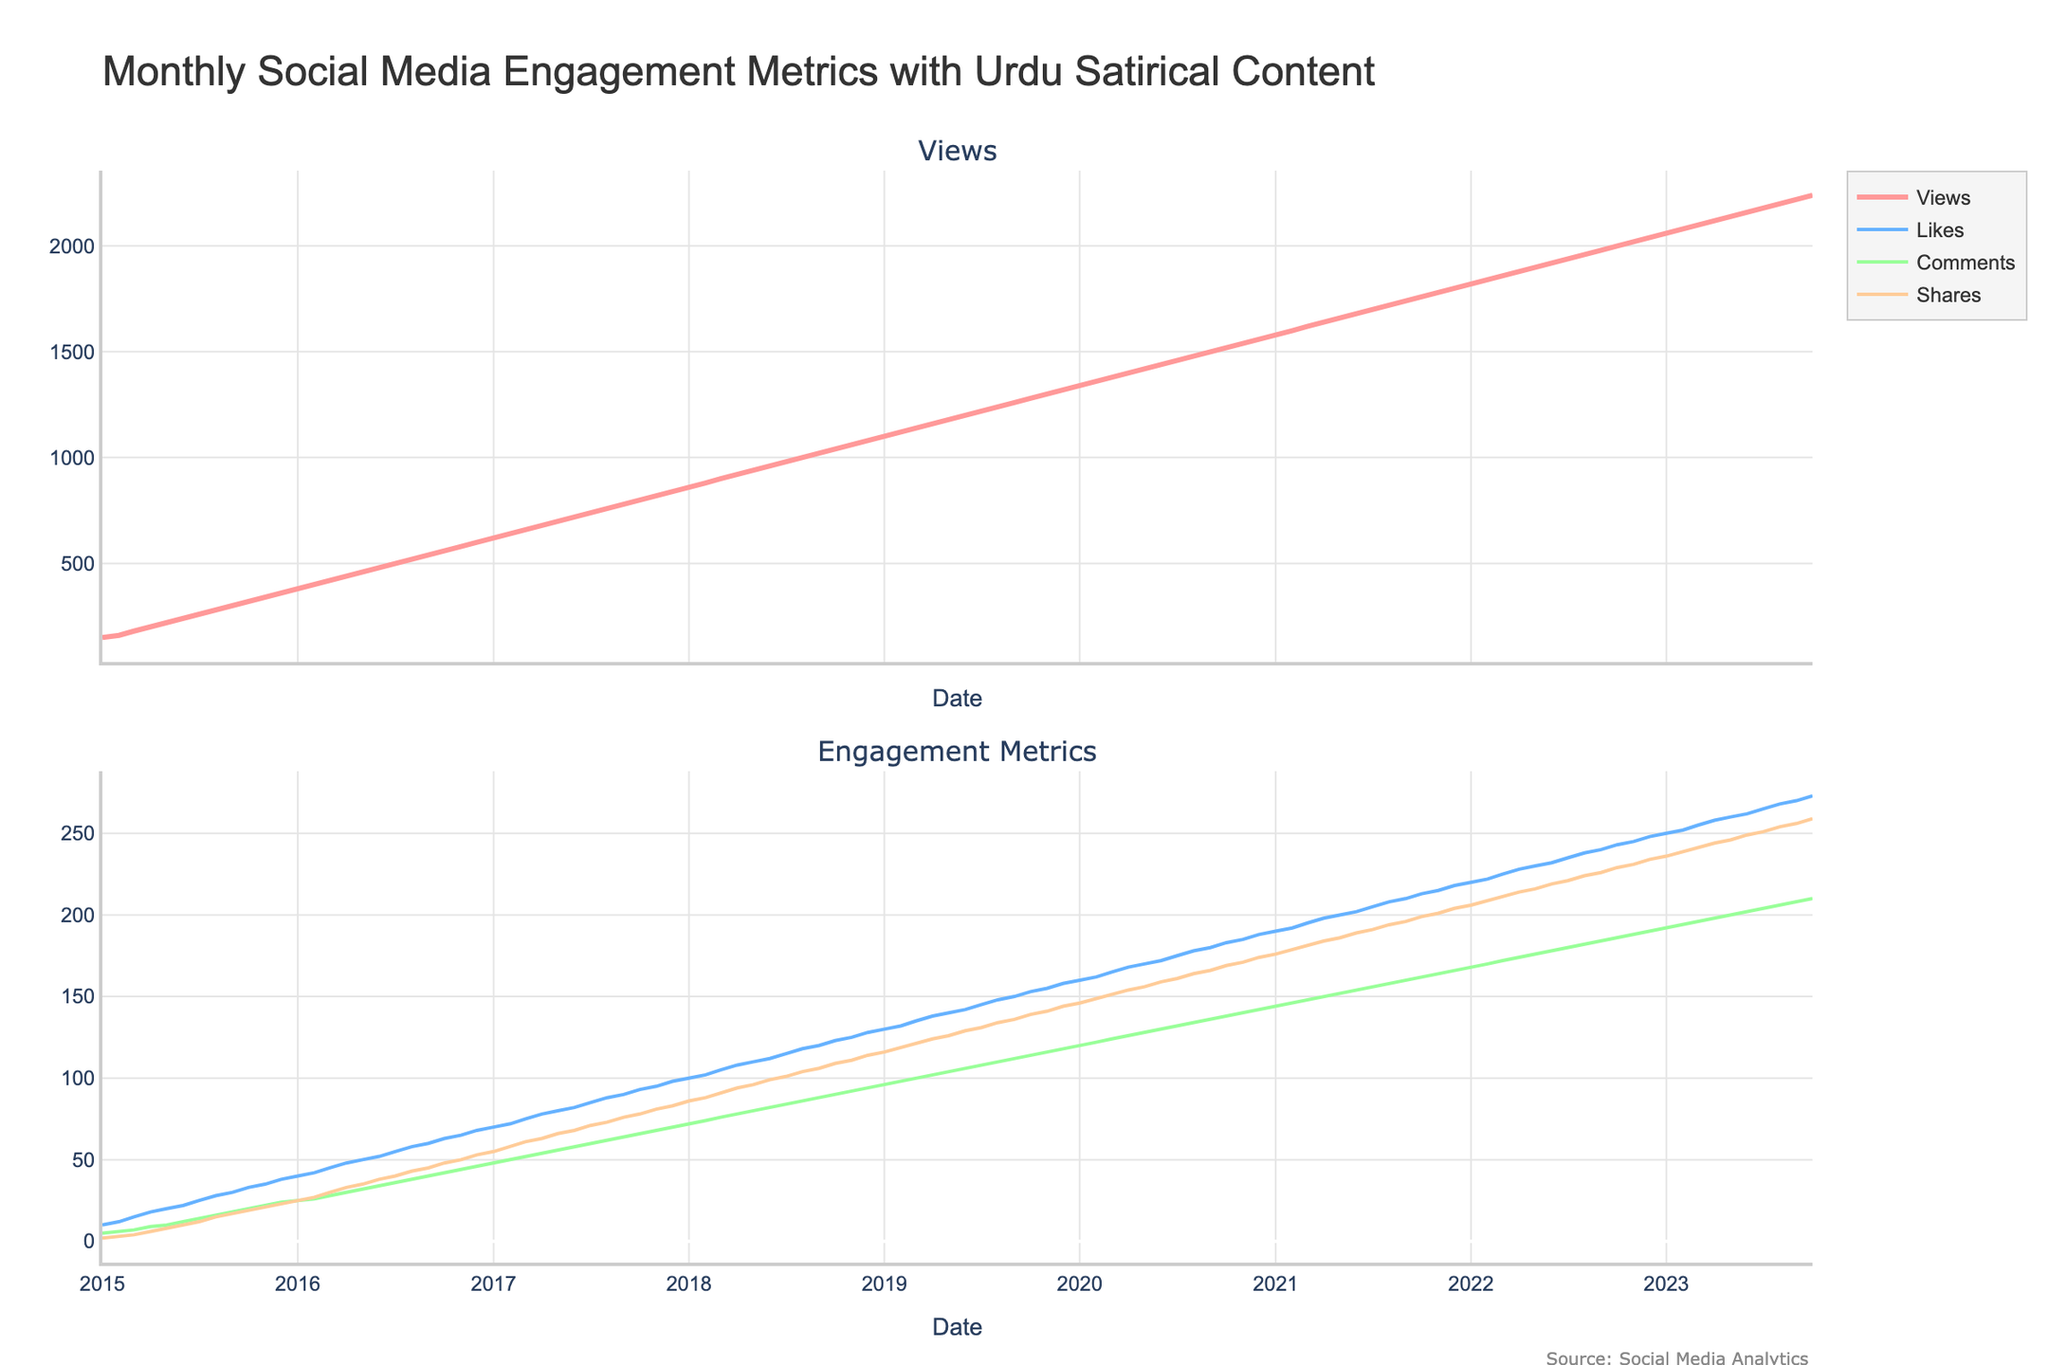What is the title of the plot? The title is prominently displayed at the top. It is "Monthly Social Media Engagement Metrics with Urdu Satirical Content".
Answer: Monthly Social Media Engagement Metrics with Urdu Satirical Content How many subplots are there, and what are their titles? The figure contains two subplots. These titles are visible above each subplot. The first subplot's title is "Views" and the second subplot's title is "Engagement Metrics".
Answer: Two; "Views" and "Engagement Metrics" Which metric has the highest value overall, and what is it? By looking at the Y-axes of both subplots and the highest point reached, it is clear that "Views" has the highest overall value. The maximum value for Views is 2,240 in 2023-10.
Answer: Views; 2,240 Which color represents the "Shares" metric in the second subplot? Each metric is assigned a distinct color. The "Shares" metric is plotted with the orange line in the second subplot.
Answer: Orange What is the average number of Views from 2015 to 2019? To find the average number of Views, sum the monthly Views from 2015 to 2019 and divide by the number of months. The sum of Views from 2015-01 to 2019-12 is 27,600, and there are 60 months in this period. The average is 27,600 / 60 = 460.
Answer: 460 Between which months did the 'Likes' metric show the most significant increase? To find the significant increase, observe the steepest slope for 'Likes' in the second subplot. The most substantial increase occurred between September 2019 and October 2019 when 'Likes' jumped noticeably.
Answer: September 2019 to October 2019 How did the trend of Comments change from 2020-01 to 2021-12? Observe the curve for Comments in the second subplot. It steadily increased from 120 in 2020-01 to 166 in 2021-12, showing a positive growth trend.
Answer: Steadily increased How did the 'Likes' metric change from the start to the end of 2018? Observe the values for 'Likes' at the start (January) and the end (December) of 2018 in the second subplot. It increased from 100 in January 2018 to 128 in December 2018.
Answer: Increased from 100 to 128 Compare the number of Views and Shares in the month 2020-06. Which was greater? Locate the values for both Views and Shares in June 2020 within the plot. Views are 1440, and Shares are 159. Therefore, Views are greater.
Answer: Views were greater What is the overall trend observed for all metrics from 2015 to 2023? By evaluating both subplots for overall patterns, all metrics (Views, Likes, Comments, Shares) show an upward trend from 2015 to 2023, indicating increasing engagement over time.
Answer: Upward trend 